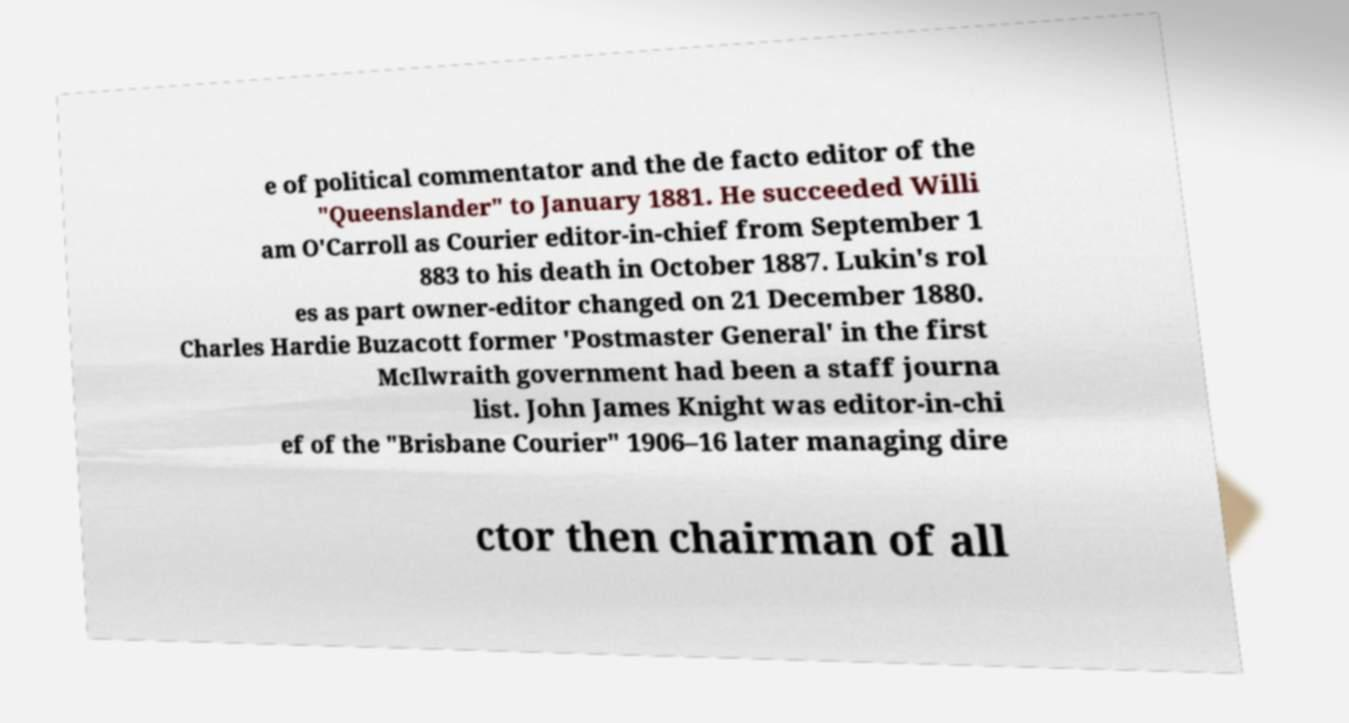For documentation purposes, I need the text within this image transcribed. Could you provide that? e of political commentator and the de facto editor of the "Queenslander" to January 1881. He succeeded Willi am O'Carroll as Courier editor-in-chief from September 1 883 to his death in October 1887. Lukin's rol es as part owner-editor changed on 21 December 1880. Charles Hardie Buzacott former 'Postmaster General' in the first McIlwraith government had been a staff journa list. John James Knight was editor-in-chi ef of the "Brisbane Courier" 1906–16 later managing dire ctor then chairman of all 